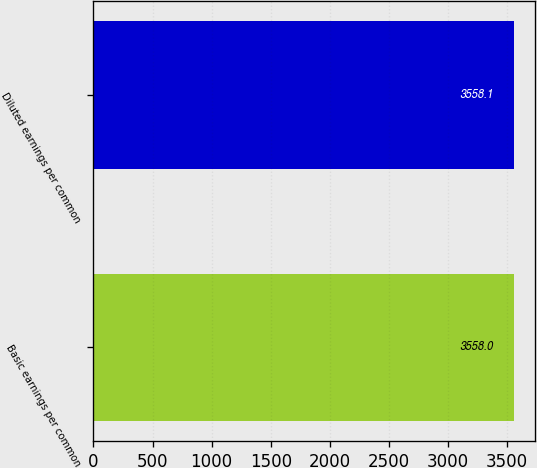<chart> <loc_0><loc_0><loc_500><loc_500><bar_chart><fcel>Basic earnings per common<fcel>Diluted earnings per common<nl><fcel>3558<fcel>3558.1<nl></chart> 